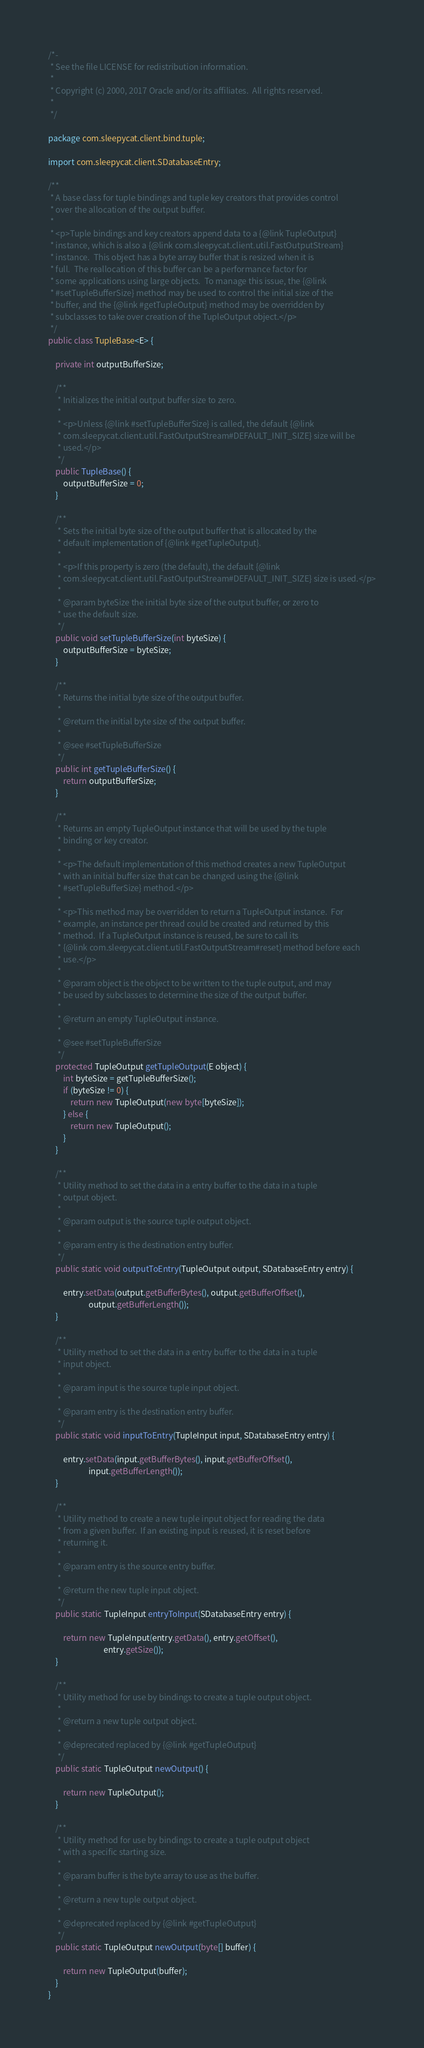Convert code to text. <code><loc_0><loc_0><loc_500><loc_500><_Java_>/*-
 * See the file LICENSE for redistribution information.
 *
 * Copyright (c) 2000, 2017 Oracle and/or its affiliates.  All rights reserved.
 *
 */

package com.sleepycat.client.bind.tuple;

import com.sleepycat.client.SDatabaseEntry;

/**
 * A base class for tuple bindings and tuple key creators that provides control
 * over the allocation of the output buffer.
 *
 * <p>Tuple bindings and key creators append data to a {@link TupleOutput}
 * instance, which is also a {@link com.sleepycat.client.util.FastOutputStream}
 * instance.  This object has a byte array buffer that is resized when it is
 * full.  The reallocation of this buffer can be a performance factor for
 * some applications using large objects.  To manage this issue, the {@link
 * #setTupleBufferSize} method may be used to control the initial size of the
 * buffer, and the {@link #getTupleOutput} method may be overridden by
 * subclasses to take over creation of the TupleOutput object.</p>
 */
public class TupleBase<E> {

    private int outputBufferSize;

    /**
     * Initializes the initial output buffer size to zero.
     *
     * <p>Unless {@link #setTupleBufferSize} is called, the default {@link
     * com.sleepycat.client.util.FastOutputStream#DEFAULT_INIT_SIZE} size will be
     * used.</p>
     */
    public TupleBase() {
        outputBufferSize = 0;
    }

    /**
     * Sets the initial byte size of the output buffer that is allocated by the
     * default implementation of {@link #getTupleOutput}.
     *
     * <p>If this property is zero (the default), the default {@link
     * com.sleepycat.client.util.FastOutputStream#DEFAULT_INIT_SIZE} size is used.</p>
     *
     * @param byteSize the initial byte size of the output buffer, or zero to
     * use the default size.
     */
    public void setTupleBufferSize(int byteSize) {
        outputBufferSize = byteSize;
    }

    /**
     * Returns the initial byte size of the output buffer.
     *
     * @return the initial byte size of the output buffer.
     *
     * @see #setTupleBufferSize
     */
    public int getTupleBufferSize() {
        return outputBufferSize;
    }

    /**
     * Returns an empty TupleOutput instance that will be used by the tuple
     * binding or key creator.
     *
     * <p>The default implementation of this method creates a new TupleOutput
     * with an initial buffer size that can be changed using the {@link
     * #setTupleBufferSize} method.</p>
     *
     * <p>This method may be overridden to return a TupleOutput instance.  For
     * example, an instance per thread could be created and returned by this
     * method.  If a TupleOutput instance is reused, be sure to call its
     * {@link com.sleepycat.client.util.FastOutputStream#reset} method before each
     * use.</p>
     *
     * @param object is the object to be written to the tuple output, and may
     * be used by subclasses to determine the size of the output buffer.
     *
     * @return an empty TupleOutput instance.
     *
     * @see #setTupleBufferSize
     */
    protected TupleOutput getTupleOutput(E object) {
        int byteSize = getTupleBufferSize();
        if (byteSize != 0) {
            return new TupleOutput(new byte[byteSize]);
        } else {
            return new TupleOutput();
        }
    }

    /**
     * Utility method to set the data in a entry buffer to the data in a tuple
     * output object.
     *
     * @param output is the source tuple output object.
     *
     * @param entry is the destination entry buffer.
     */
    public static void outputToEntry(TupleOutput output, SDatabaseEntry entry) {

        entry.setData(output.getBufferBytes(), output.getBufferOffset(),
                      output.getBufferLength());
    }

    /**
     * Utility method to set the data in a entry buffer to the data in a tuple
     * input object.
     *
     * @param input is the source tuple input object.
     *
     * @param entry is the destination entry buffer.
     */
    public static void inputToEntry(TupleInput input, SDatabaseEntry entry) {

        entry.setData(input.getBufferBytes(), input.getBufferOffset(),
                      input.getBufferLength());
    }

    /**
     * Utility method to create a new tuple input object for reading the data
     * from a given buffer.  If an existing input is reused, it is reset before
     * returning it.
     *
     * @param entry is the source entry buffer.
     *
     * @return the new tuple input object.
     */
    public static TupleInput entryToInput(SDatabaseEntry entry) {

        return new TupleInput(entry.getData(), entry.getOffset(),
                              entry.getSize());
    }

    /**
     * Utility method for use by bindings to create a tuple output object.
     *
     * @return a new tuple output object.
     *
     * @deprecated replaced by {@link #getTupleOutput}
     */
    public static TupleOutput newOutput() {

        return new TupleOutput();
    }

    /**
     * Utility method for use by bindings to create a tuple output object
     * with a specific starting size.
     *
     * @param buffer is the byte array to use as the buffer.
     *
     * @return a new tuple output object.
     *
     * @deprecated replaced by {@link #getTupleOutput}
     */
    public static TupleOutput newOutput(byte[] buffer) {

        return new TupleOutput(buffer);
    }
}
</code> 